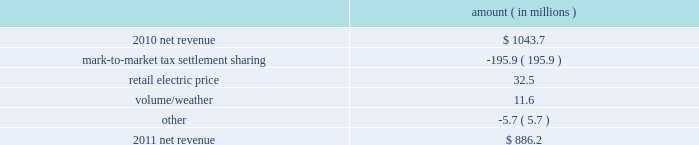Entergy louisiana , llc and subsidiaries management 2019s financial discussion and analysis plan to spin off the utility 2019s transmission business see the 201cplan to spin off the utility 2019s transmission business 201d section of entergy corporation and subsidiaries management 2019s financial discussion and analysis for a discussion of this matter , including the planned retirement of debt and preferred securities .
Results of operations net income 2011 compared to 2010 net income increased $ 242.5 million primarily due to a settlement with the irs related to the mark-to-market income tax treatment of power purchase contracts , which resulted in a $ 422 million income tax benefit .
The net income effect was partially offset by a $ 199 million regulatory charge , which reduced net revenue , because a portion of the benefit will be shared with customers .
See note 3 to the financial statements for additional discussion of the settlement and benefit sharing .
2010 compared to 2009 net income decreased slightly by $ 1.4 million primarily due to higher other operation and maintenance expenses , a higher effective income tax rate , and higher interest expense , almost entirely offset by higher net revenue .
Net revenue 2011 compared to 2010 net revenue consists of operating revenues net of : 1 ) fuel , fuel-related expenses , and gas purchased for resale , 2 ) purchased power expenses , and 3 ) other regulatory charges ( credits ) .
Following is an analysis of the change in net revenue comparing 2011 to 2010 .
Amount ( in millions ) .
The mark-to-market tax settlement sharing variance results from a regulatory charge because a portion of the benefits of a settlement with the irs related to the mark-to-market income tax treatment of power purchase contracts will be shared with customers , slightly offset by the amortization of a portion of that charge beginning in october 2011 .
See notes 3 and 8 to the financial statements for additional discussion of the settlement and benefit sharing .
The retail electric price variance is primarily due to a formula rate plan increase effective may 2011 .
See note 2 to the financial statements for discussion of the formula rate plan increase. .
What is the growth rate in net revenue from 2010 to 2011? 
Computations: ((886.2 - 1043.7) / 1043.7)
Answer: -0.15091. 